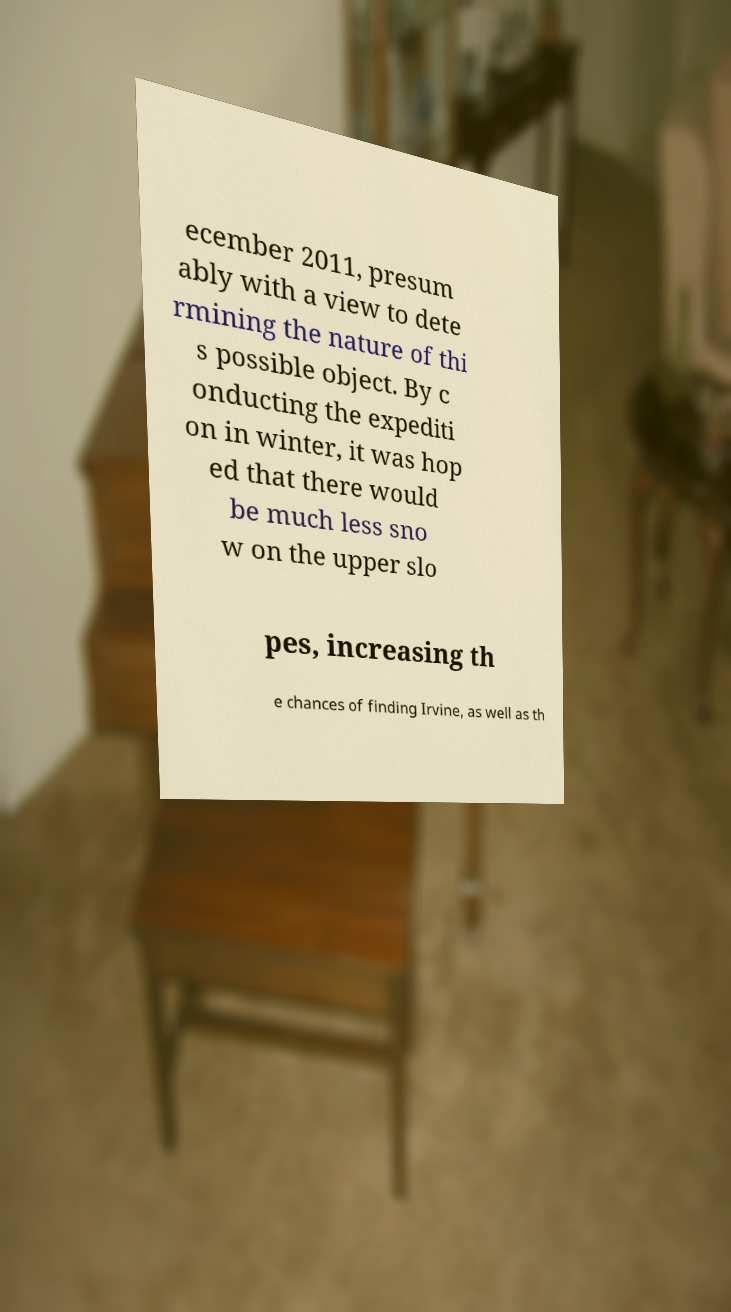There's text embedded in this image that I need extracted. Can you transcribe it verbatim? ecember 2011, presum ably with a view to dete rmining the nature of thi s possible object. By c onducting the expediti on in winter, it was hop ed that there would be much less sno w on the upper slo pes, increasing th e chances of finding Irvine, as well as th 